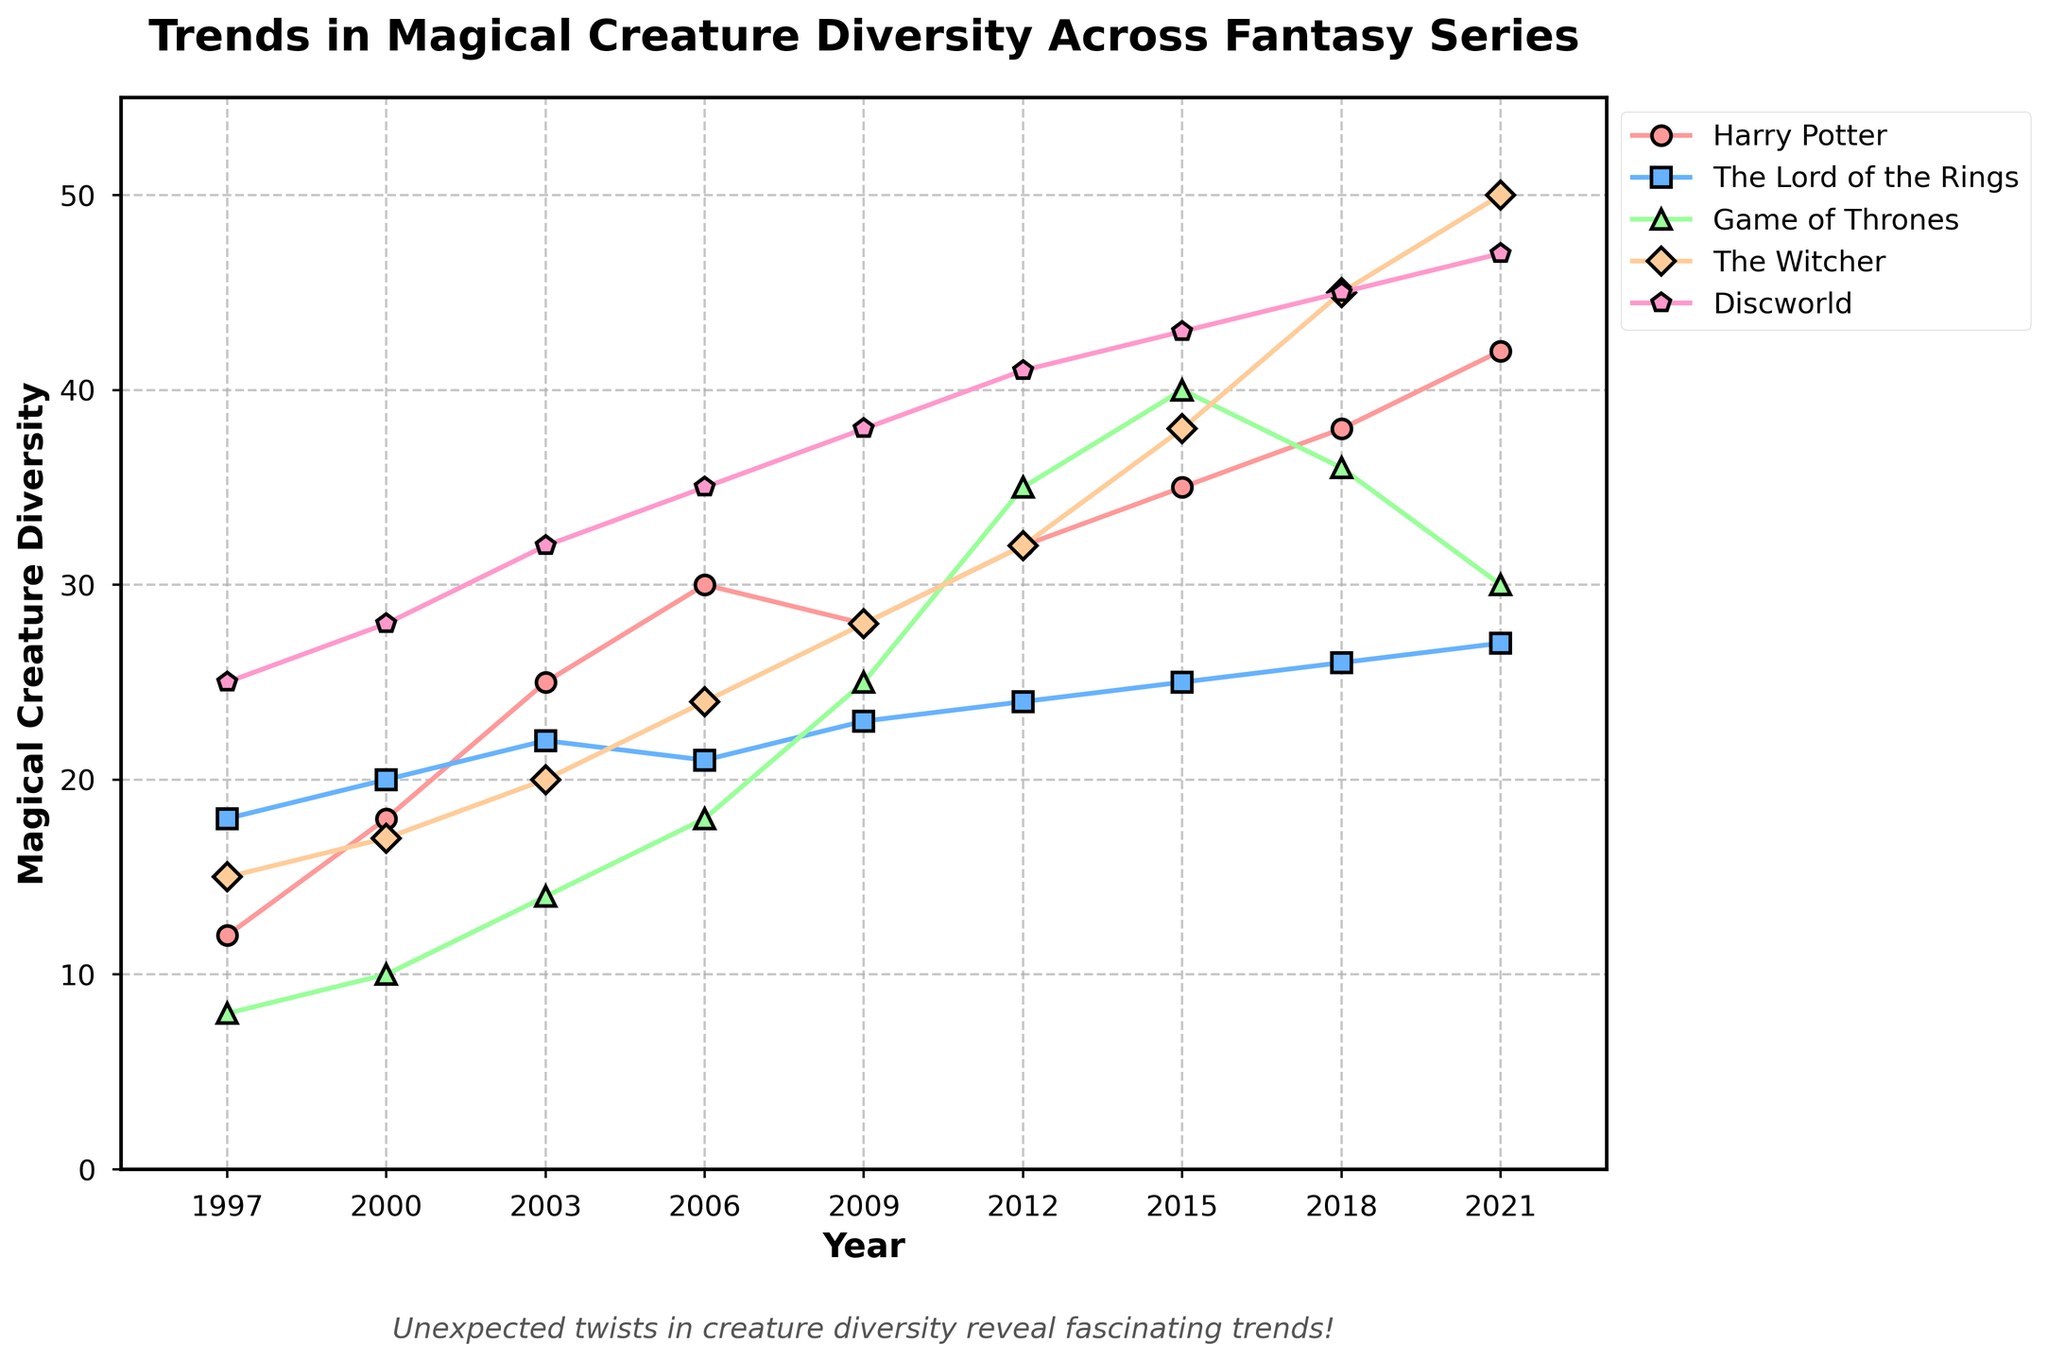Which series had the highest diversity of magical creatures in 2021? Looking at the values on the y-axis for each series in 2021, Discworld has the highest mark at 47.
Answer: Discworld How does the increase in the number of magical creatures in Game of Thrones between 2009 and 2012 compare to the increase in The Witcher for the same period? For Game of Thrones, the number increases from 25 in 2009 to 35 in 2012, an increase of 10. For The Witcher, it increases from 28 to 32, an increase of 4.
Answer: Game of Thrones increased by 10, The Witcher increased by 4 Between 1997 and 2021, which series had the steepest rise in magical creature diversity? Calculating the change for each series: Harry Potter (42-12=30), The Lord of the Rings (27-18=9), Game of Thrones (30-8=22), The Witcher (50-15=35), and Discworld (47-25=22). The Witcher had the highest increase.
Answer: The Witcher In which year did Discworld surpass Harry Potter in creature diversity for the first time? Comparing values over the years until Discworld consistently surpasses Harry Potter. Up to 2000, Discworld maintains higher values than Harry Potter.
Answer: 1997 Which series had the most surprising decrease or stagnation in creature diversity? Observing the trends, The Lord of the Rings shows a slight decrease from 2006 to 2009 and then stagnates.
Answer: The Lord of the Rings In 2015, which fantasy series had similar levels of creature diversity and what were they? Examining the graph values for 2015, Game of Thrones and The Witcher both had close values, specifically, 40 and 38 respectively.
Answer: Game of Thrones and The Witcher Compare the growth in creature diversity from 2000 to 2018 between Harry Potter and Game of Thrones. Which series showed greater growth? For Harry Potter: 38 - 18 = 20. For Game of Thrones: 36 - 10 = 26. Game of Thrones showed greater growth.
Answer: Game of Thrones What is the difference in diversity between the most and least diverse series in 2006? The Witcher has 24 (highest) and The Lord of the Rings has 21 (lowest), difference is 24 - 21 = 3.
Answer: 3 What year did Game of Thrones achieve its highest point of magical creature diversity in the dataset? Reviewing the tallest point of the Game of Thrones line shows it peaks in 2015 with a value of 40.
Answer: 2015 